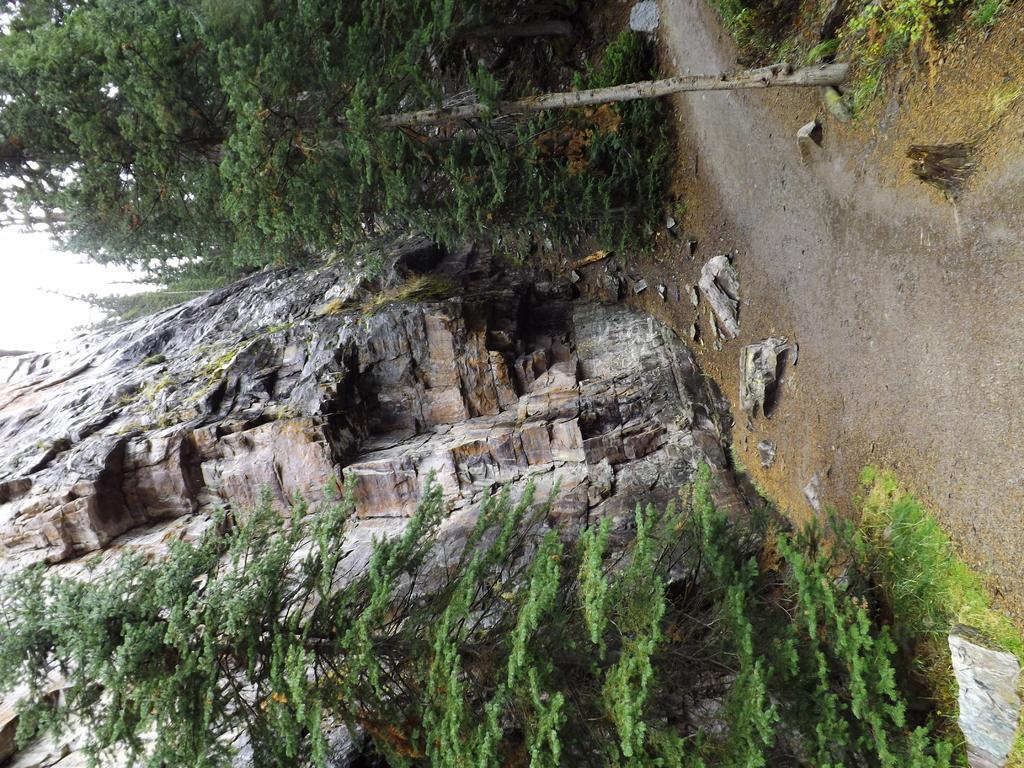Can you describe this image briefly? In this picture we can see the stone mountains. At the top and bottom we can see the trees. On the right there is a road. In the top right corner we can see plants and grass. On the left there is a sky. 